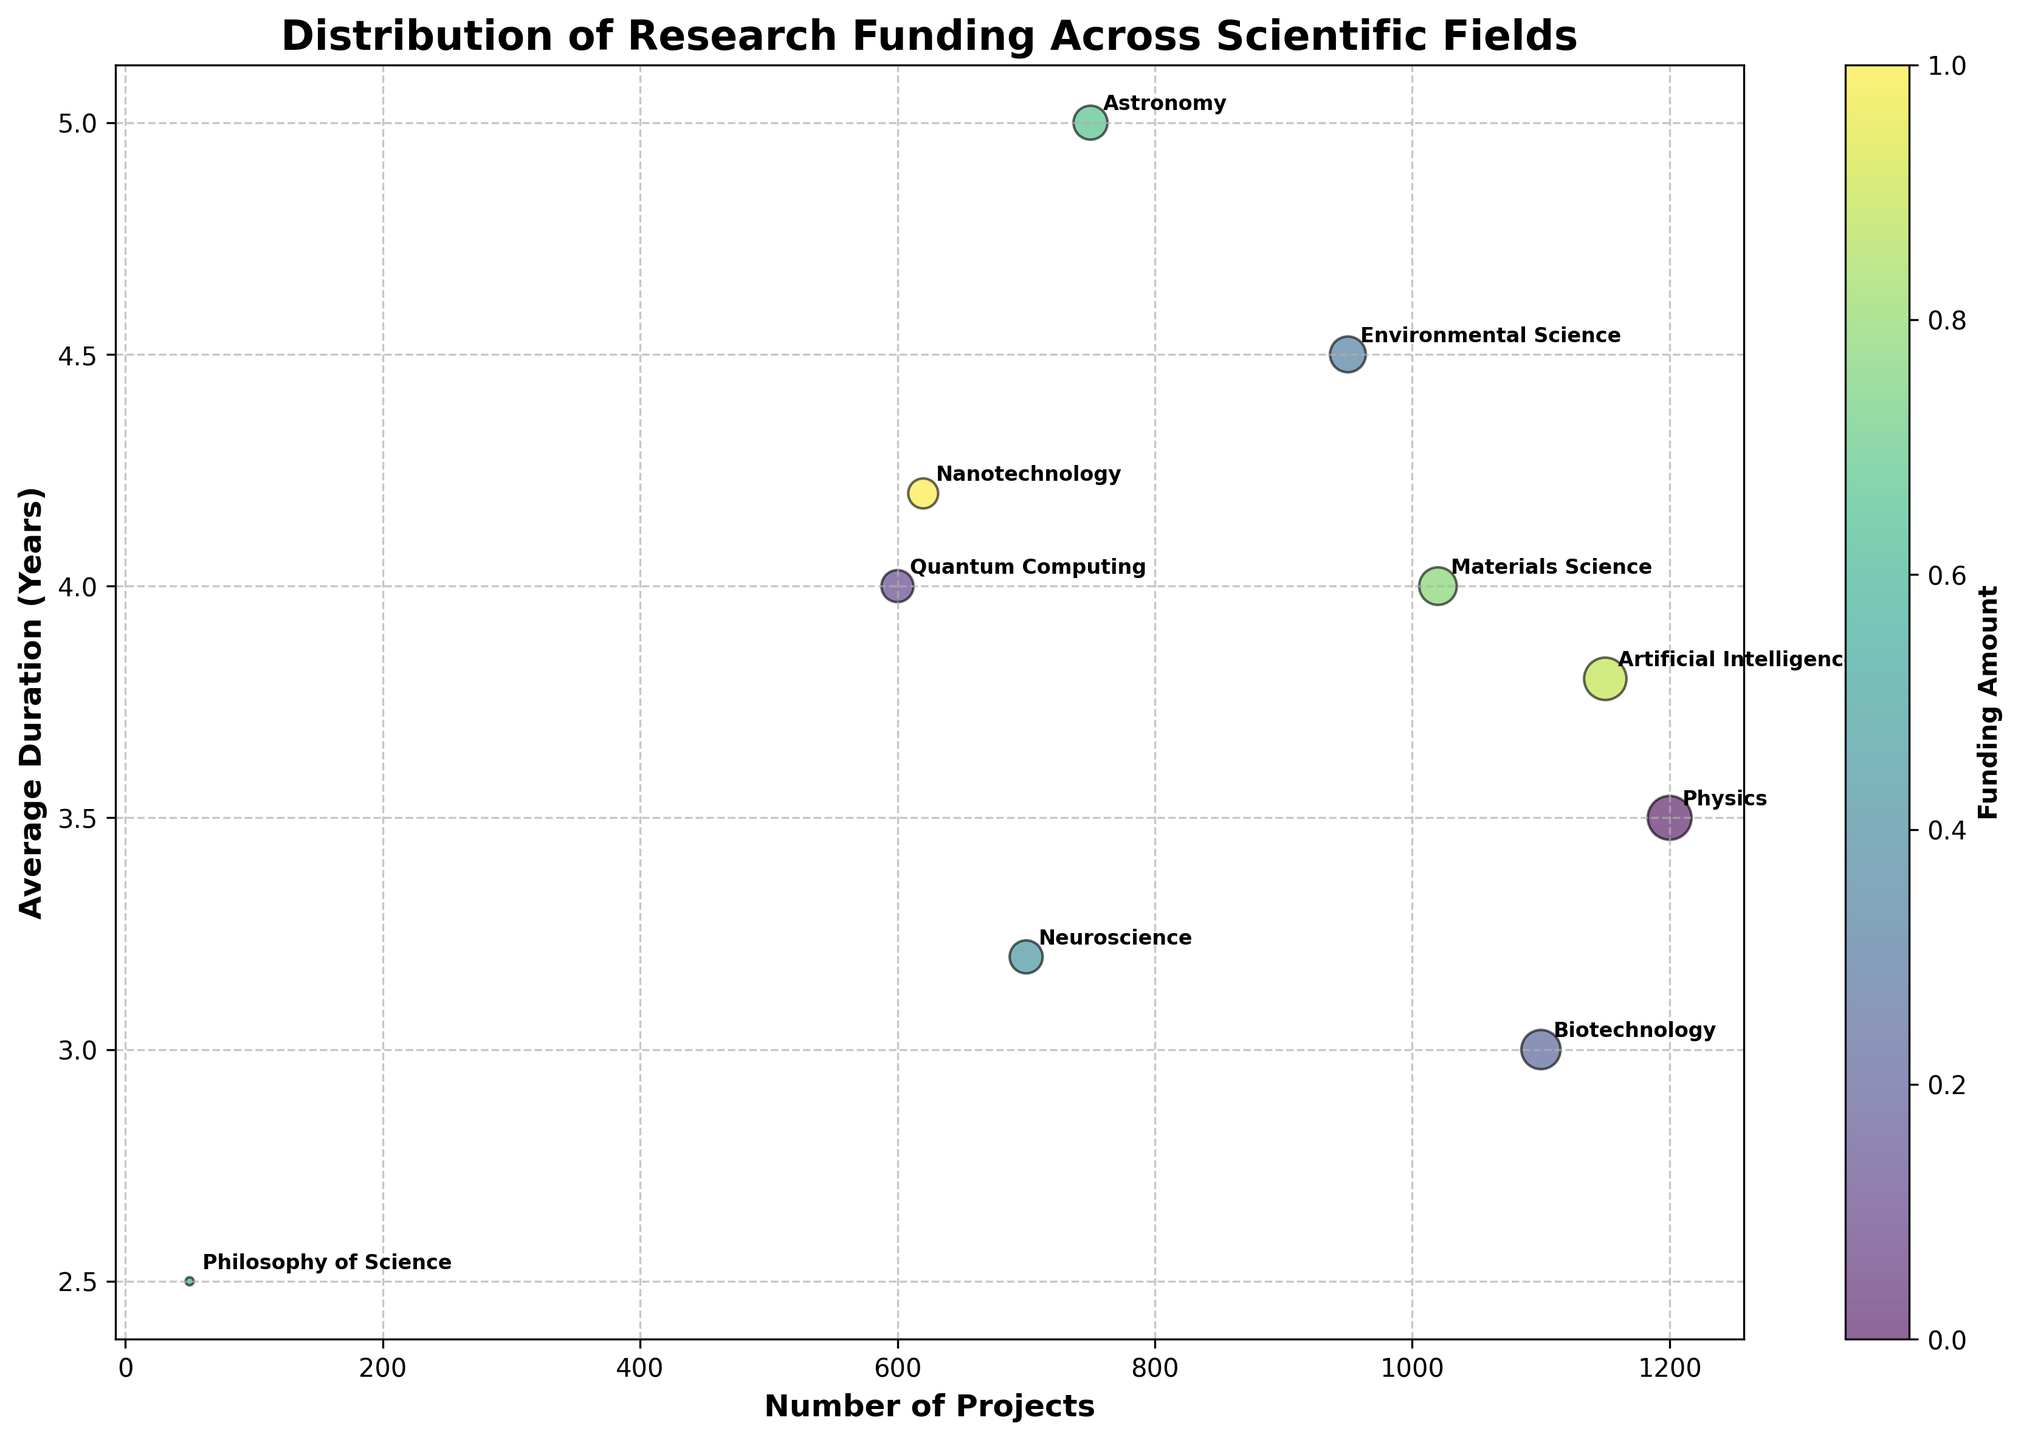What is the title of the figure? The title is usually located at the top center of a figure. In this case, the title is given as 'Distribution of Research Funding Across Scientific Fields.'
Answer: Distribution of Research Funding Across Scientific Fields Which scientific field has the largest number of projects? To determine this, one must examine the x-axis (Number of Projects) and identify the field associated with the highest value. The data point farthest to the right is 'Physics' with 1200 projects.
Answer: Physics How many fields have an average project duration of more than 4 years? Fields above the y-axis value of 4 years are counted. They include 'Quantum Computing,' 'Environmental Science,' 'Astronomy,' and 'Nanotechnology,' totaling 4 fields.
Answer: 4 What is the average duration of projects in Quantum Computing and Nanotechnology? Sum the average durations of Quantum Computing (4) and Nanotechnology (4.2) and divide by 2. (4 + 4.2)/2 = 4.1
Answer: 4.1 Which field has the smallest bubble size and what does this indicate? The smallest bubble represents the 'Philosophy of Science' field, indicating that it has the smallest amount of funding, which is $500 million.
Answer: Philosophy of Science Is there a field that has both above average funding and project duration? 'Astronomy' fits this profile with funding of $9000 million and an average duration of 5 years, both above the dataset averages.
Answer: Astronomy Which field has more projects: Biotechnology or Artificial Intelligence? By comparing the x-axis positions of 'Biotechnology' (1100 projects) and 'Artificial Intelligence' (1150 projects), we see that Artificial Intelligence has more projects.
Answer: Artificial Intelligence Which fields have higher funding but shorter average duration compared to Quantum Computing? Only 'Artificial Intelligence' has higher funding ($14000 million) and a shorter average duration (3.8 years) compared to Quantum Computing.
Answer: Artificial Intelligence What relationship can be observed between the number of projects and the size of funding bubbles? Generally, fields with a larger number of projects (e.g., 'Physics', 'Artificial Intelligence') also have a larger bubble size, indicating higher funding levels.
Answer: Larger number of projects, larger funding How does the average project duration in Neuroscience compare to that in Biotechnology? The y-axis shows Neuroscience's duration as 3.2 years and Biotechnology's as 3 years. Neuroscience thus has a slightly longer average project duration.
Answer: 3.2 years vs 3 years 